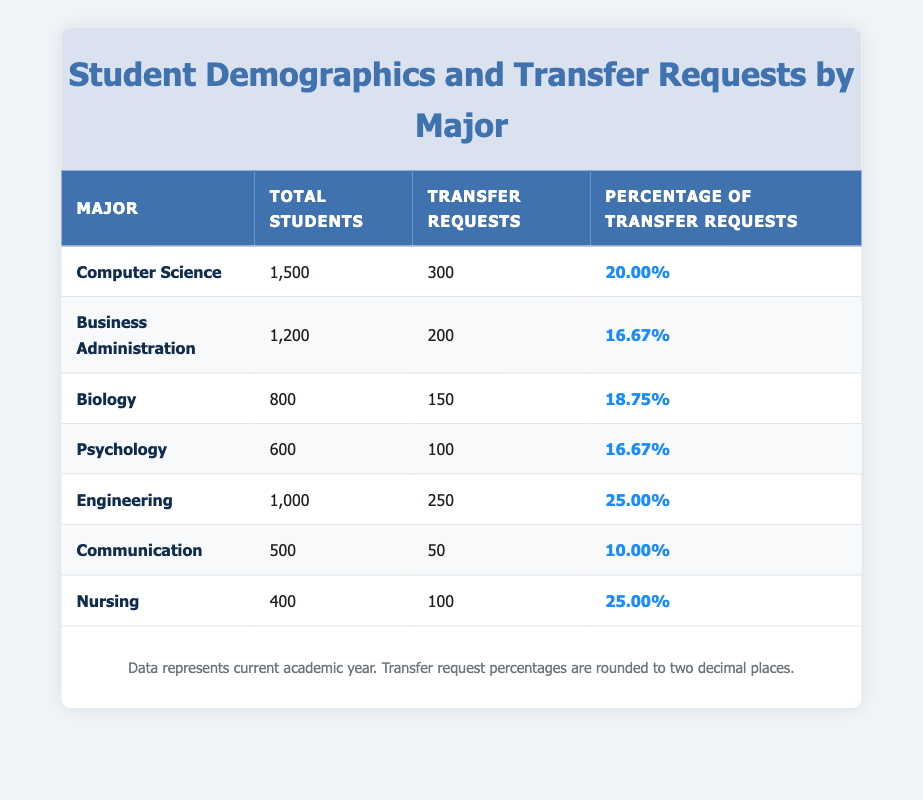What is the total number of students majoring in Nursing? The table lists the total number of students for each major. For Nursing, the entry shows 400 total students.
Answer: 400 Which major has the highest percentage of transfer requests? To find the major with the highest percentage, we compare all percentages listed. Engineering and Nursing both have the highest percentage at 25%.
Answer: Engineering and Nursing How many transfer requests were made by Psychology majors? Referring to the table, the number of transfer requests for Psychology is shown as 100.
Answer: 100 What is the average percentage of transfer requests across all majors? To calculate the average, add all the percentages (20 + 16.67 + 18.75 + 16.67 + 25 + 10 + 25) which equals 132.09 and divide by the number of majors (7): 132.09 / 7 ≈ 18.86.
Answer: 18.86 Is the number of transfer requests for Biology greater than that for Communication? From the table, Biology has 150 transfer requests, while Communication has 50. Since 150 is greater than 50, the statement is true.
Answer: Yes Which major has the lowest total number of students? By examining the "Total Students" column, Communication has the lowest number with 500 total students.
Answer: Communication How many more students are in Computer Science compared to Psychology? The total number of students in Computer Science is 1500, and in Psychology, it is 600. Subtracting these gives 1500 - 600 = 900.
Answer: 900 What percentage of Computer Science students requested to transfer? The table states that 20% of Computer Science students requested to transfer.
Answer: 20% Which major has both the highest number of transfer requests and the lowest percentage of transfer requests? Looking at the table, Computer Science has the highest transfer requests at 300 but has a lower percentage (20%) than Engineering and Nursing. Hence, it doesn't fulfill both criteria. Engineering and Nursing both have 250 requests but have a percentage of 25%. The answer, therefore, is none.
Answer: None 